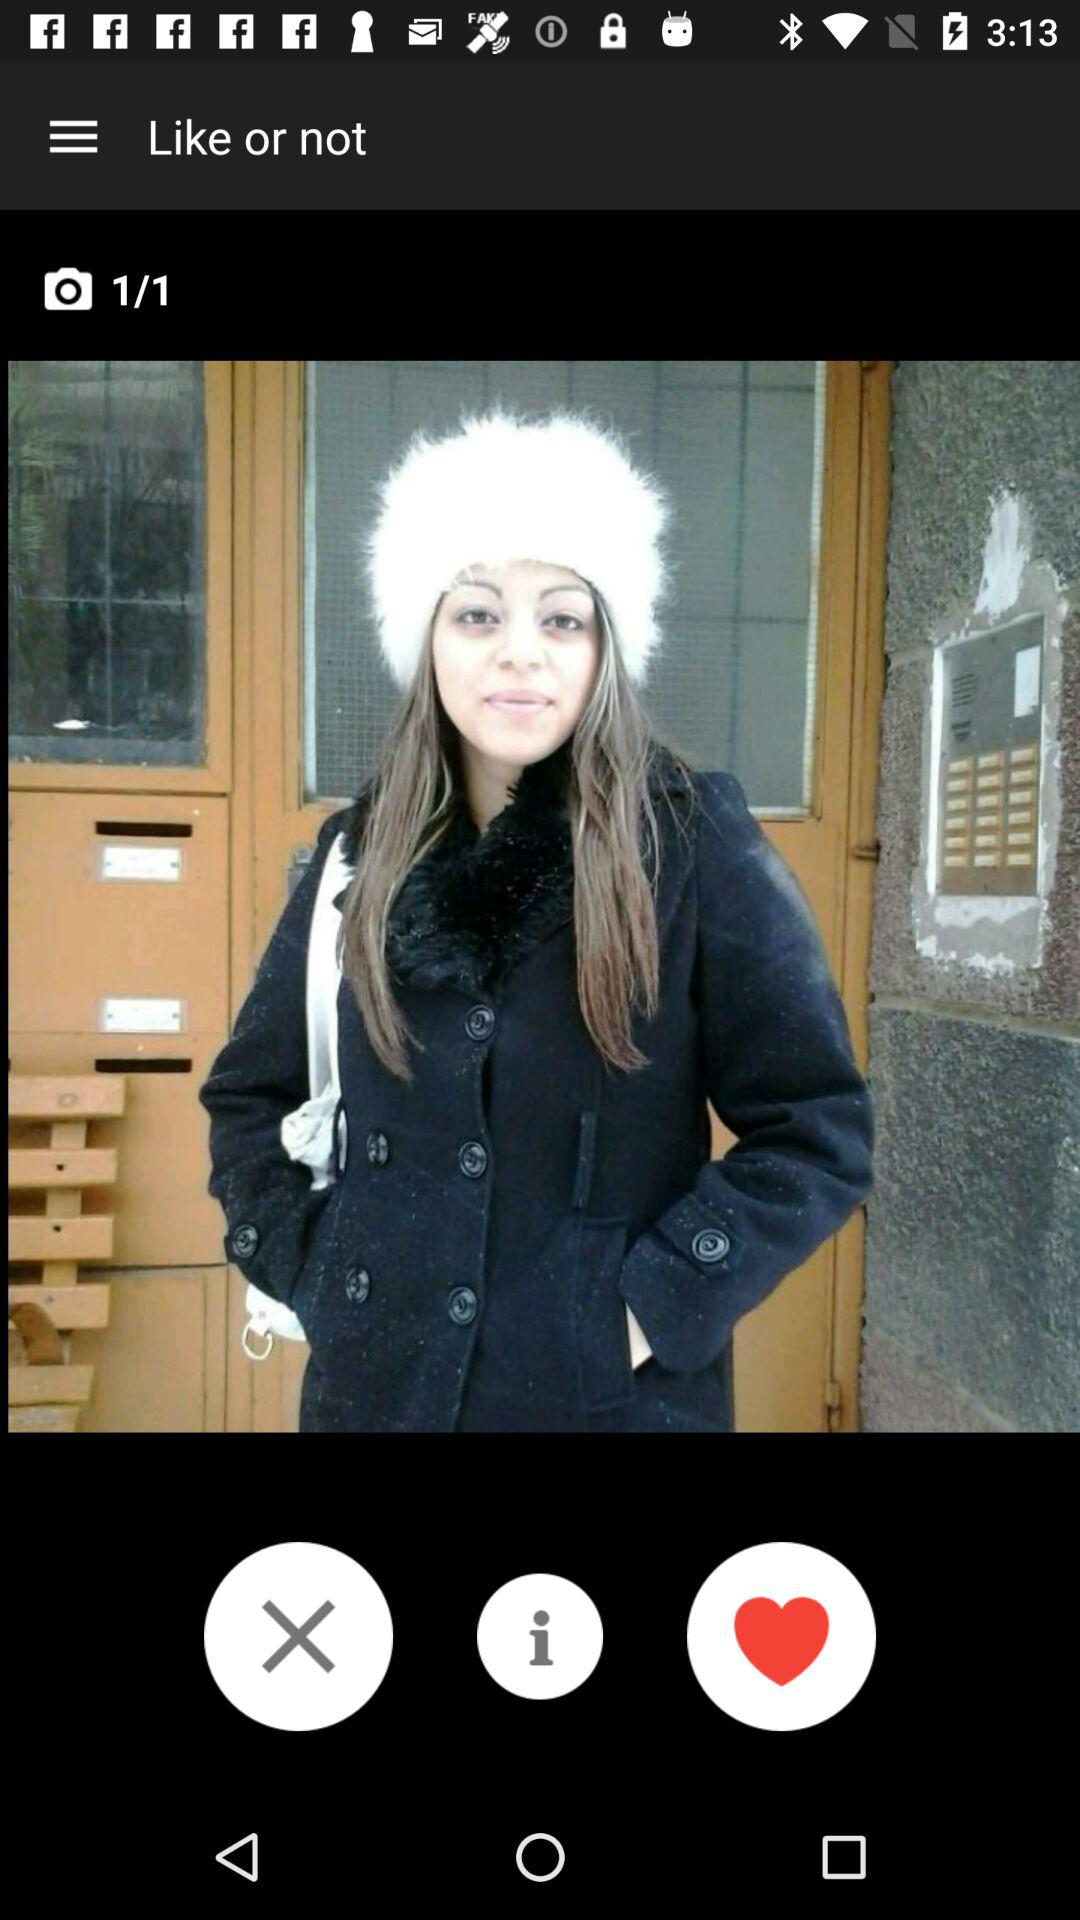How many images in total are there? There is 1 image in total. 